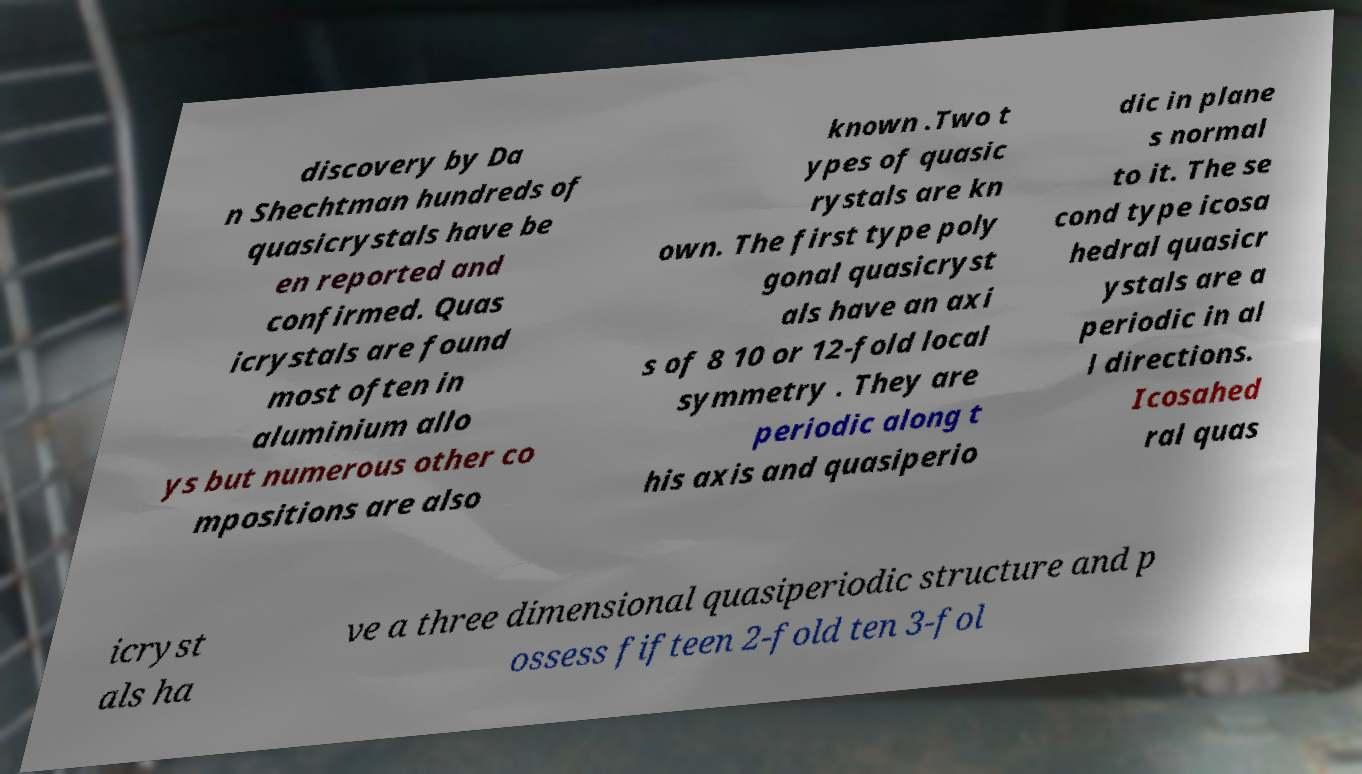Could you assist in decoding the text presented in this image and type it out clearly? discovery by Da n Shechtman hundreds of quasicrystals have be en reported and confirmed. Quas icrystals are found most often in aluminium allo ys but numerous other co mpositions are also known .Two t ypes of quasic rystals are kn own. The first type poly gonal quasicryst als have an axi s of 8 10 or 12-fold local symmetry . They are periodic along t his axis and quasiperio dic in plane s normal to it. The se cond type icosa hedral quasicr ystals are a periodic in al l directions. Icosahed ral quas icryst als ha ve a three dimensional quasiperiodic structure and p ossess fifteen 2-fold ten 3-fol 